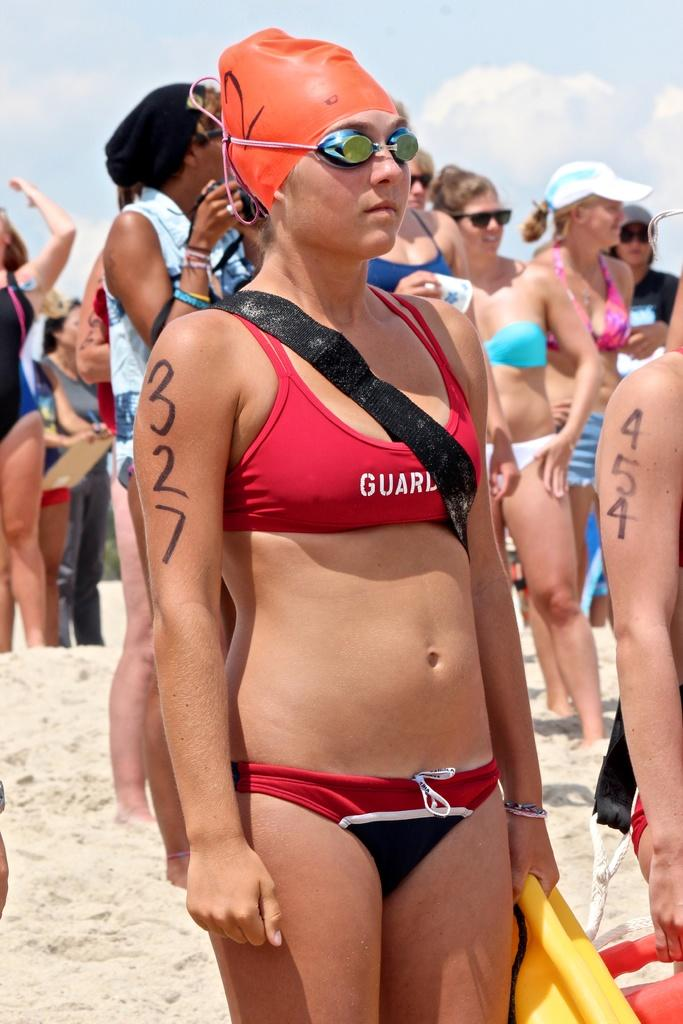<image>
Present a compact description of the photo's key features. A woman has a swimsuit top that says guard and 327 on her right upper arm. 